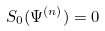<formula> <loc_0><loc_0><loc_500><loc_500>S _ { 0 } ( \Psi ^ { ( n ) } ) = 0</formula> 